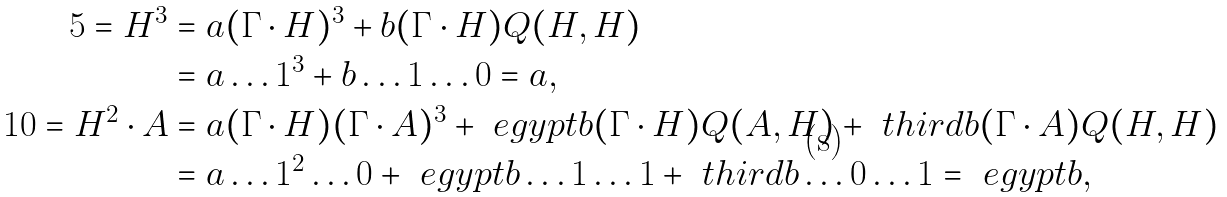<formula> <loc_0><loc_0><loc_500><loc_500>5 = H ^ { 3 } & = a ( \Gamma \cdot H ) ^ { 3 } + b ( \Gamma \cdot H ) Q ( H , H ) \\ & = a \dots 1 ^ { 3 } + b \dots 1 \dots 0 = a , \\ 1 0 = H ^ { 2 } \cdot A & = a ( \Gamma \cdot H ) ( \Gamma \cdot A ) ^ { 3 } + \ e g y p t b ( \Gamma \cdot H ) Q ( A , H ) + \ t h i r d b ( \Gamma \cdot A ) Q ( H , H ) \\ & = a \dots 1 ^ { 2 } \dots 0 + \ e g y p t b \dots 1 \dots 1 + \ t h i r d b \dots 0 \dots 1 = \ e g y p t b ,</formula> 